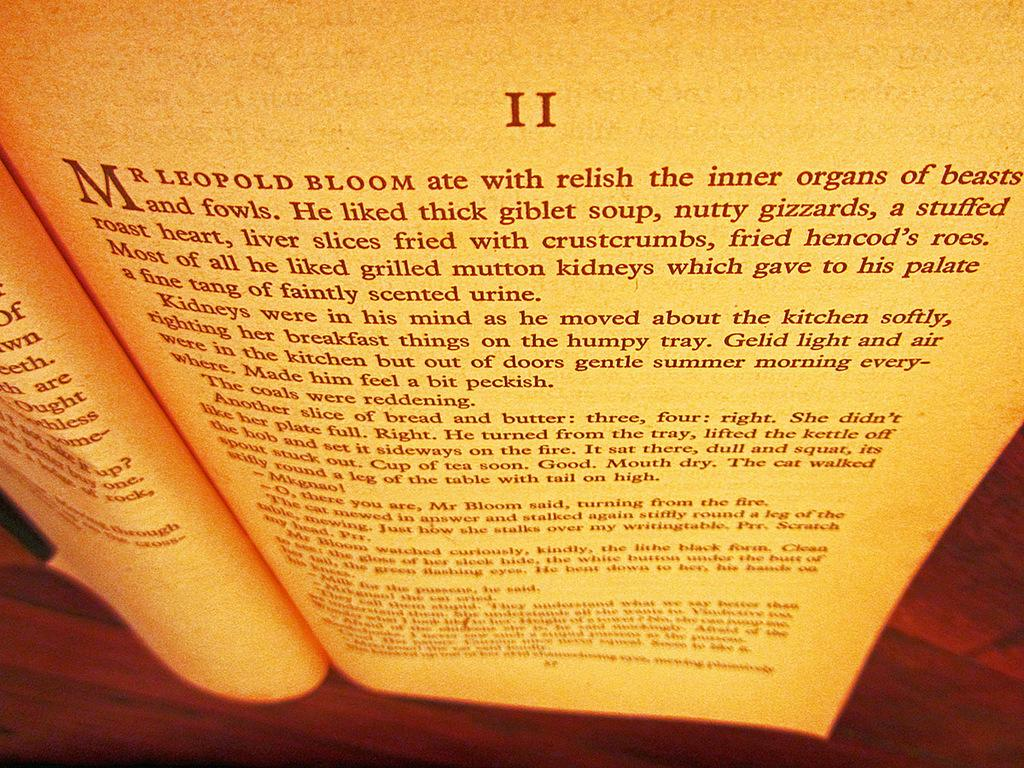<image>
Render a clear and concise summary of the photo. Mr LEOPOLD BLOOM ate with relish is written on the page. 